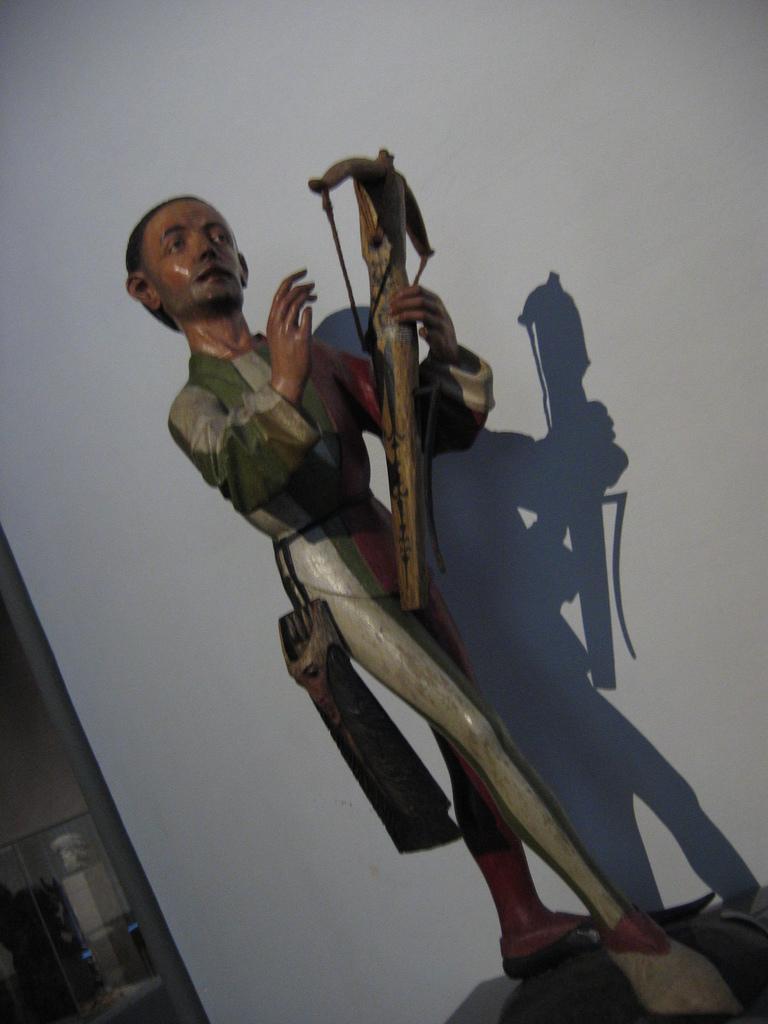Describe this image in one or two sentences. In the foreground of this picture, we see a toy person standing and holding a bow in his hand. In the background, there is a wall. 